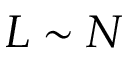<formula> <loc_0><loc_0><loc_500><loc_500>L \sim N</formula> 